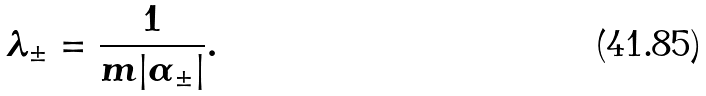Convert formula to latex. <formula><loc_0><loc_0><loc_500><loc_500>\lambda _ { \pm } = \frac { 1 } { m | \alpha _ { \pm } | } .</formula> 